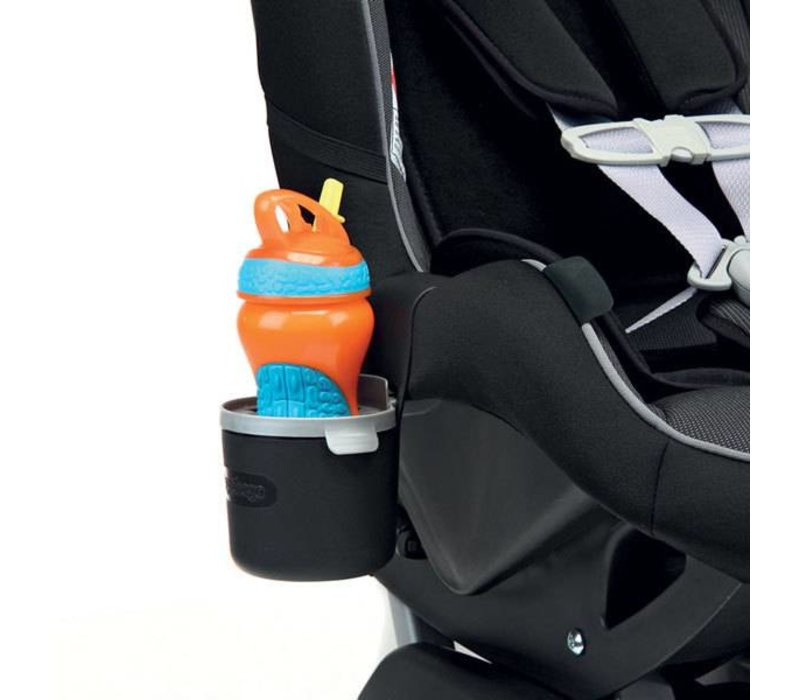What additional safety features could be inferred from the other components of the car seat not directly visible in the image? Though not directly visible, the car seat might also include built-in side impact protection, which offers extra safety by surrounding the head, neck, and spine with shock-absorbing materials. There may also be an adjustable headrest to accommodate the growing height of a child, ensuring continued protection and comfort. 